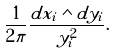<formula> <loc_0><loc_0><loc_500><loc_500>\frac { 1 } { 2 \pi } \frac { d x _ { i } \wedge d y _ { i } } { y _ { i } ^ { 2 } } .</formula> 